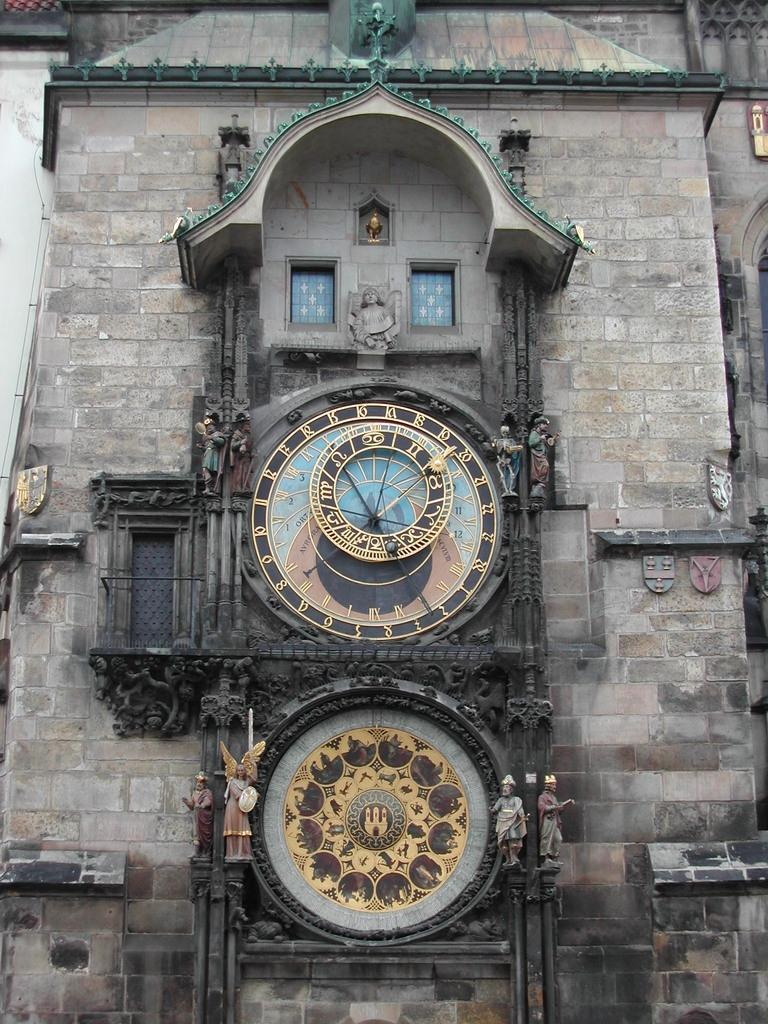<image>
Write a terse but informative summary of the picture. A huge clock numbered 1-24 is on the side of a building. 